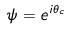Convert formula to latex. <formula><loc_0><loc_0><loc_500><loc_500>\psi = e ^ { i \theta _ { c } }</formula> 